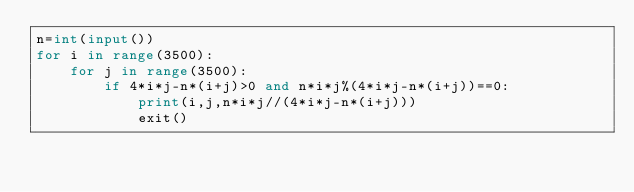Convert code to text. <code><loc_0><loc_0><loc_500><loc_500><_Python_>n=int(input())
for i in range(3500):
    for j in range(3500):
        if 4*i*j-n*(i+j)>0 and n*i*j%(4*i*j-n*(i+j))==0:
            print(i,j,n*i*j//(4*i*j-n*(i+j)))
            exit()</code> 